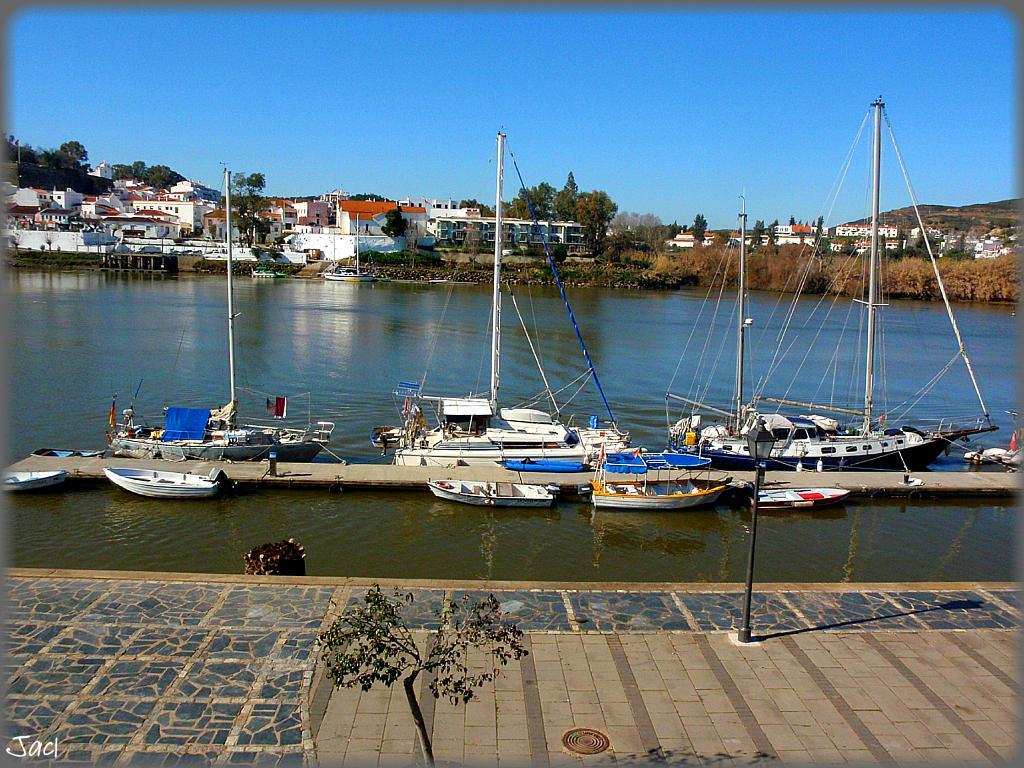What is on the water in the image? There are boats on the water in the image. What type of vegetation can be seen in the image? There are trees in the image. What type of structures are present in the image? There are houses in the image. What is visible in the background of the image? The sky is visible in the background of the image. How many pies are being baked in the image? There is no indication of pies or baking in the image. What type of nut is growing on the trees in the image? There is no mention of specific types of nuts or trees in the image. 